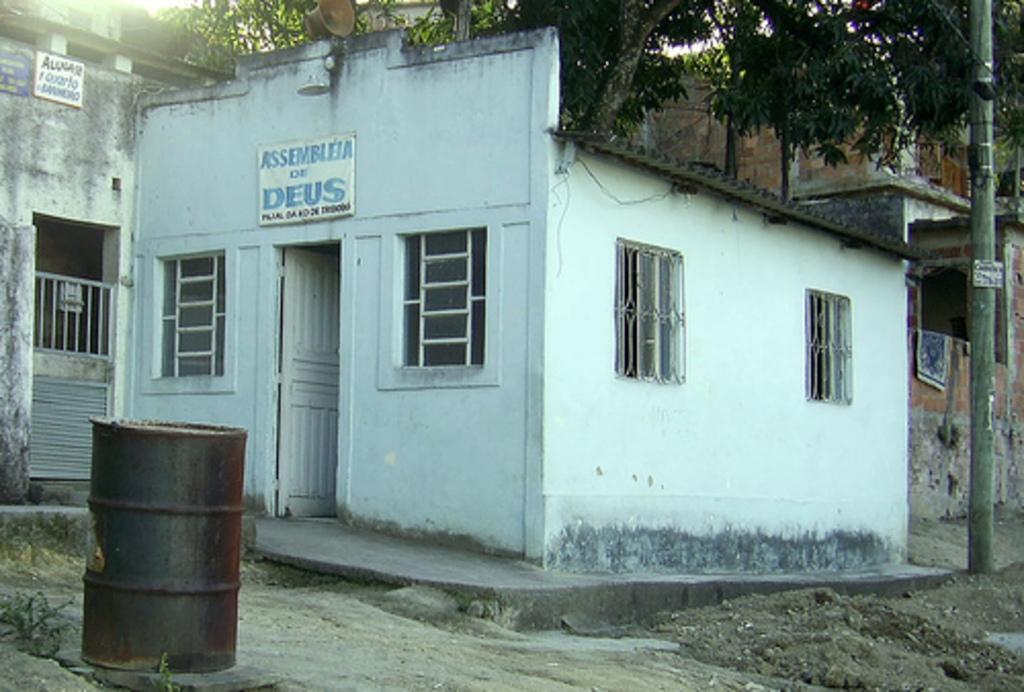What does the sign say above the door?
Offer a terse response. Assembleia of deus. 